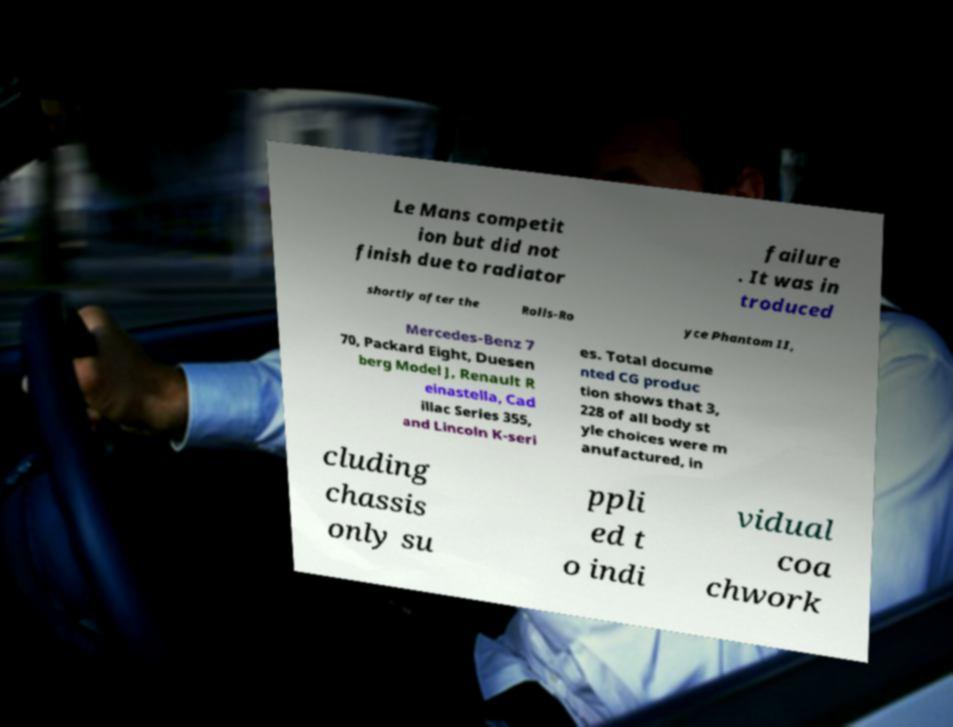I need the written content from this picture converted into text. Can you do that? Le Mans competit ion but did not finish due to radiator failure . It was in troduced shortly after the Rolls-Ro yce Phantom II, Mercedes-Benz 7 70, Packard Eight, Duesen berg Model J, Renault R einastella, Cad illac Series 355, and Lincoln K-seri es. Total docume nted CG produc tion shows that 3, 228 of all body st yle choices were m anufactured, in cluding chassis only su ppli ed t o indi vidual coa chwork 